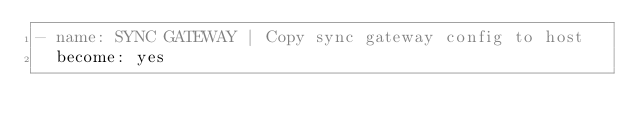Convert code to text. <code><loc_0><loc_0><loc_500><loc_500><_YAML_>- name: SYNC GATEWAY | Copy sync gateway config to host
  become: yes</code> 